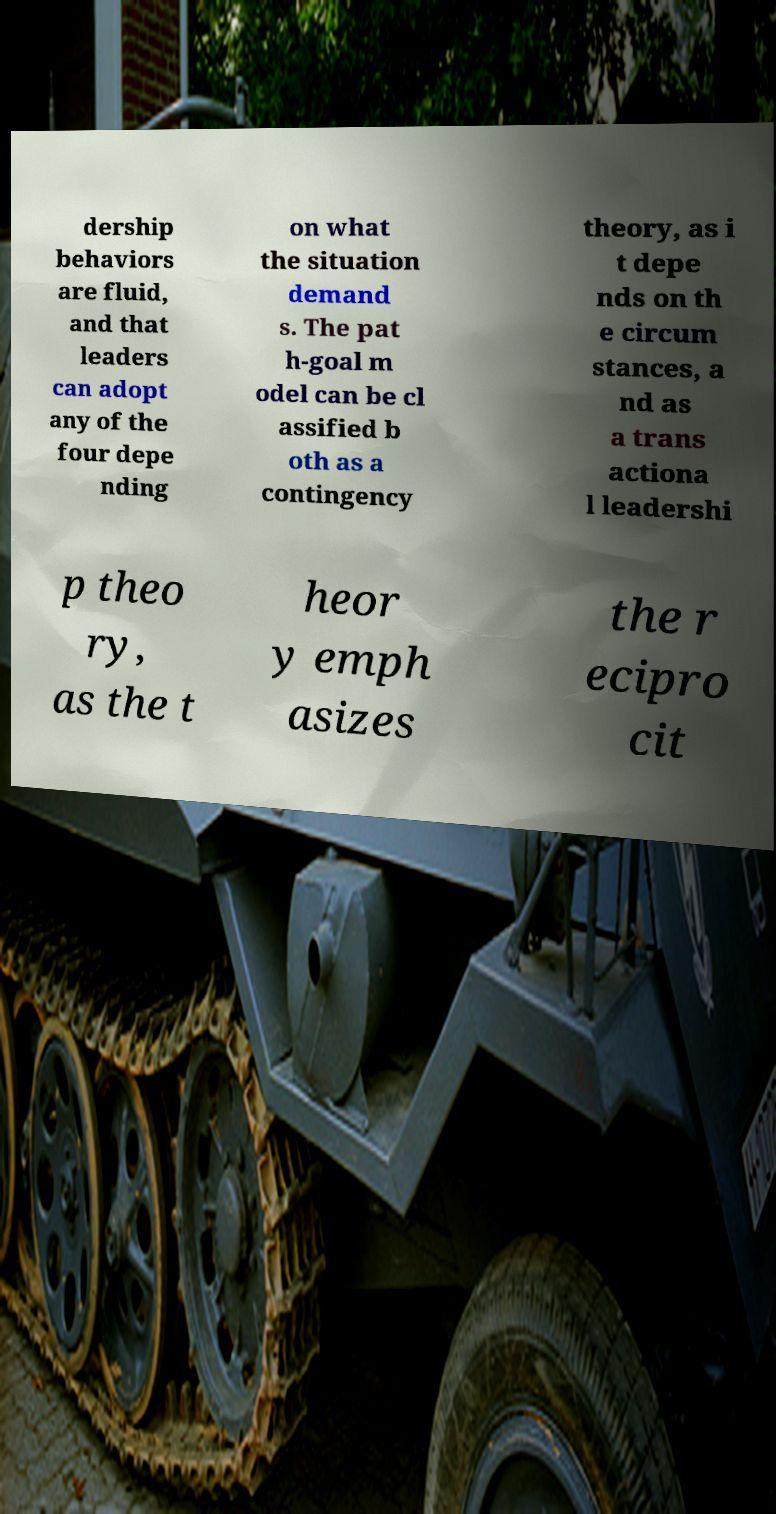Can you read and provide the text displayed in the image?This photo seems to have some interesting text. Can you extract and type it out for me? dership behaviors are fluid, and that leaders can adopt any of the four depe nding on what the situation demand s. The pat h-goal m odel can be cl assified b oth as a contingency theory, as i t depe nds on th e circum stances, a nd as a trans actiona l leadershi p theo ry, as the t heor y emph asizes the r ecipro cit 